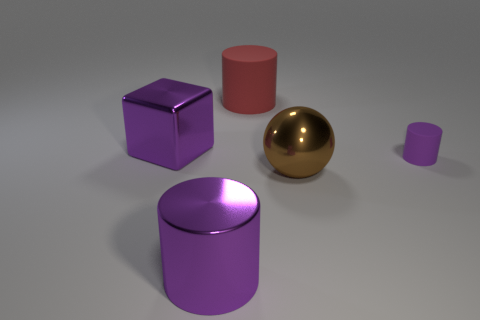Is there any other thing that is the same size as the purple rubber cylinder?
Offer a terse response. No. What number of other objects are the same material as the red cylinder?
Keep it short and to the point. 1. Are there more shiny things that are right of the red object than large metal blocks that are in front of the small purple object?
Ensure brevity in your answer.  Yes. How many brown things are right of the small purple cylinder?
Make the answer very short. 0. Is the big red object made of the same material as the purple cylinder that is to the right of the red matte object?
Provide a short and direct response. Yes. Is there any other thing that is the same shape as the brown thing?
Offer a terse response. No. Are the block and the large brown thing made of the same material?
Provide a short and direct response. Yes. There is a cylinder that is to the right of the big brown sphere; is there a big metallic block behind it?
Ensure brevity in your answer.  Yes. How many big objects are both in front of the big red cylinder and left of the sphere?
Make the answer very short. 2. What is the shape of the matte object in front of the big rubber cylinder?
Give a very brief answer. Cylinder. 